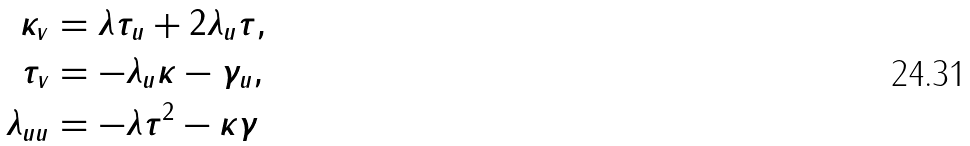Convert formula to latex. <formula><loc_0><loc_0><loc_500><loc_500>\kappa _ { v } & = \lambda \tau _ { u } + 2 \lambda _ { u } \tau , \\ \tau _ { v } & = - \lambda _ { u } \kappa - \gamma _ { u } , \\ \lambda _ { u u } & = - \lambda \tau ^ { 2 } - \kappa \gamma</formula> 